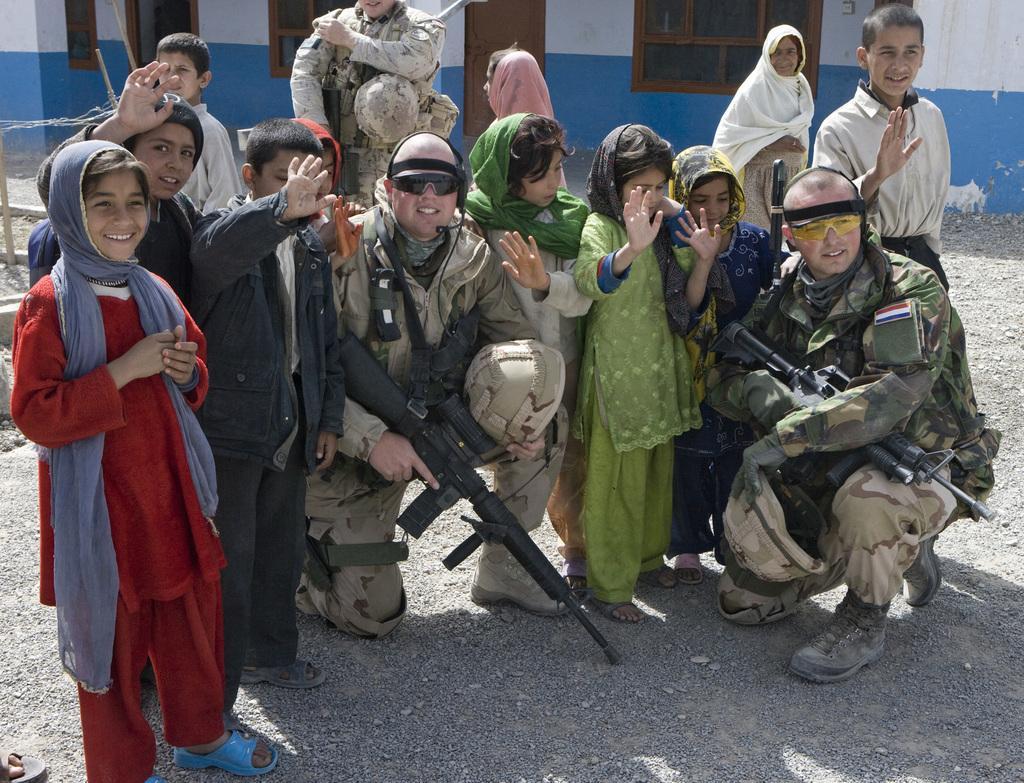Describe this image in one or two sentences. In the foreground of this image, there are people standing and squatting where three men are holding guns and carrying helmet. In the background, there are windows, door and the wall. 